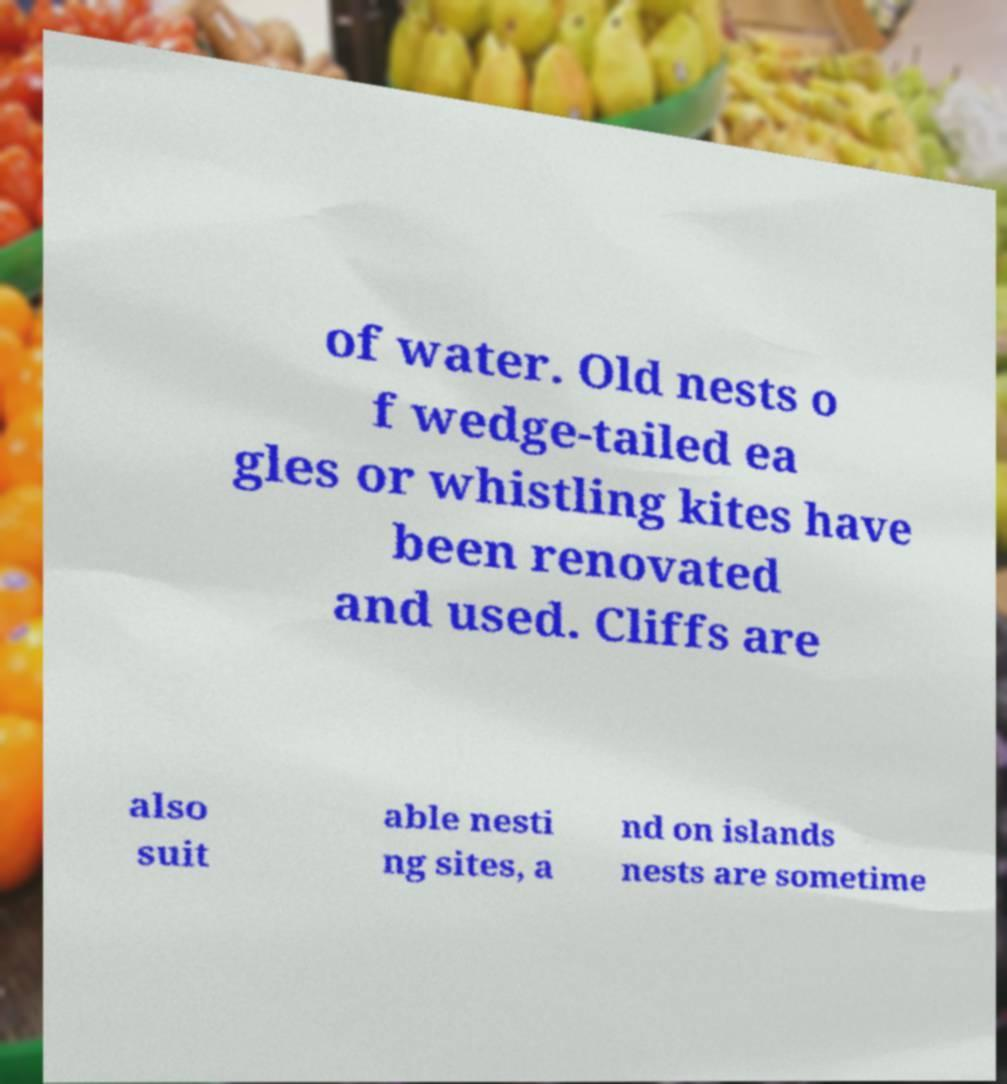Could you extract and type out the text from this image? of water. Old nests o f wedge-tailed ea gles or whistling kites have been renovated and used. Cliffs are also suit able nesti ng sites, a nd on islands nests are sometime 